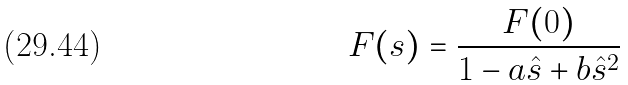Convert formula to latex. <formula><loc_0><loc_0><loc_500><loc_500>F ( s ) = \frac { F ( 0 ) } { 1 - a \hat { s } + b \hat { s } ^ { 2 } } \,</formula> 